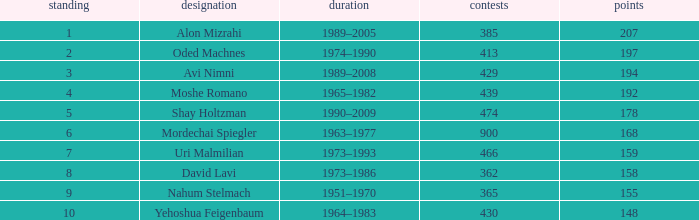What is the Rank of the player with 158 Goals in more than 362 Matches? 0.0. 